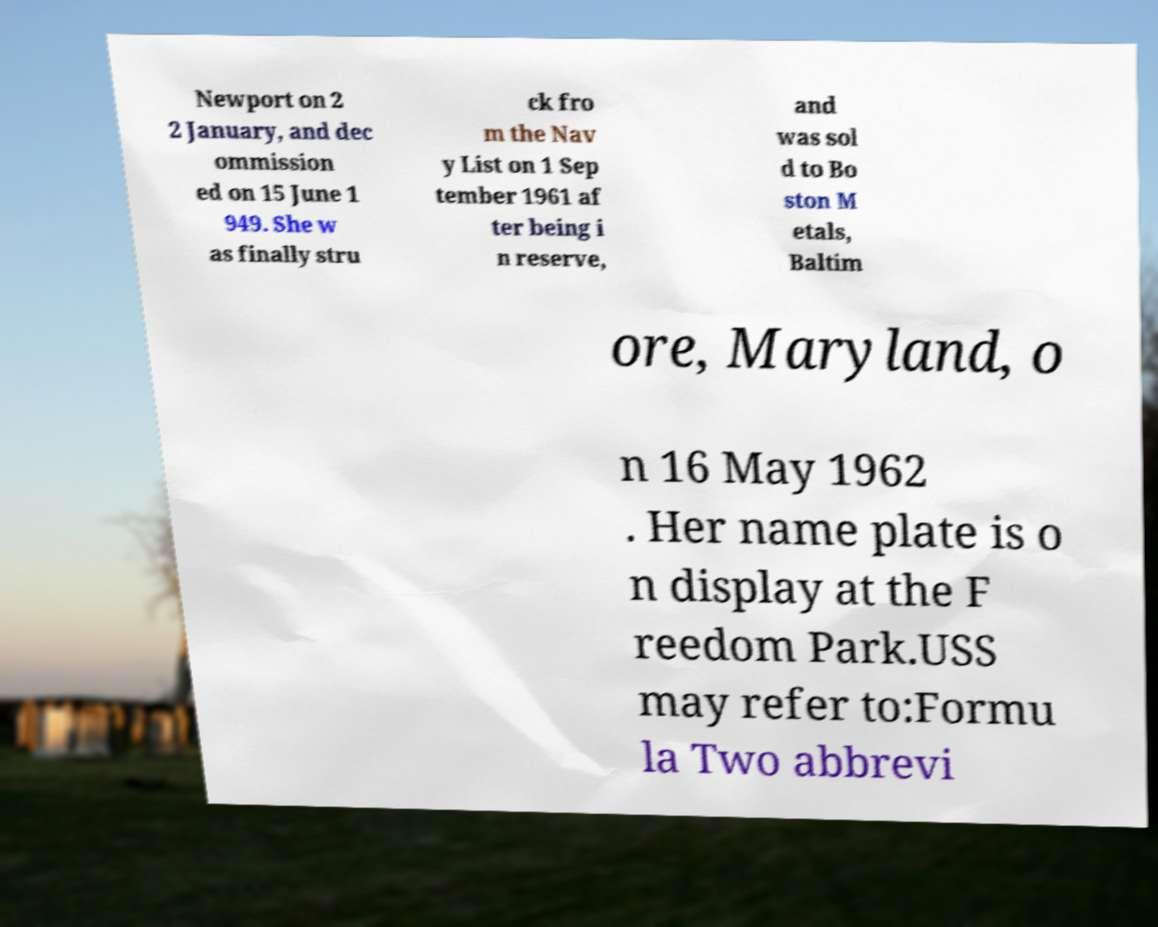Please read and relay the text visible in this image. What does it say? Newport on 2 2 January, and dec ommission ed on 15 June 1 949. She w as finally stru ck fro m the Nav y List on 1 Sep tember 1961 af ter being i n reserve, and was sol d to Bo ston M etals, Baltim ore, Maryland, o n 16 May 1962 . Her name plate is o n display at the F reedom Park.USS may refer to:Formu la Two abbrevi 